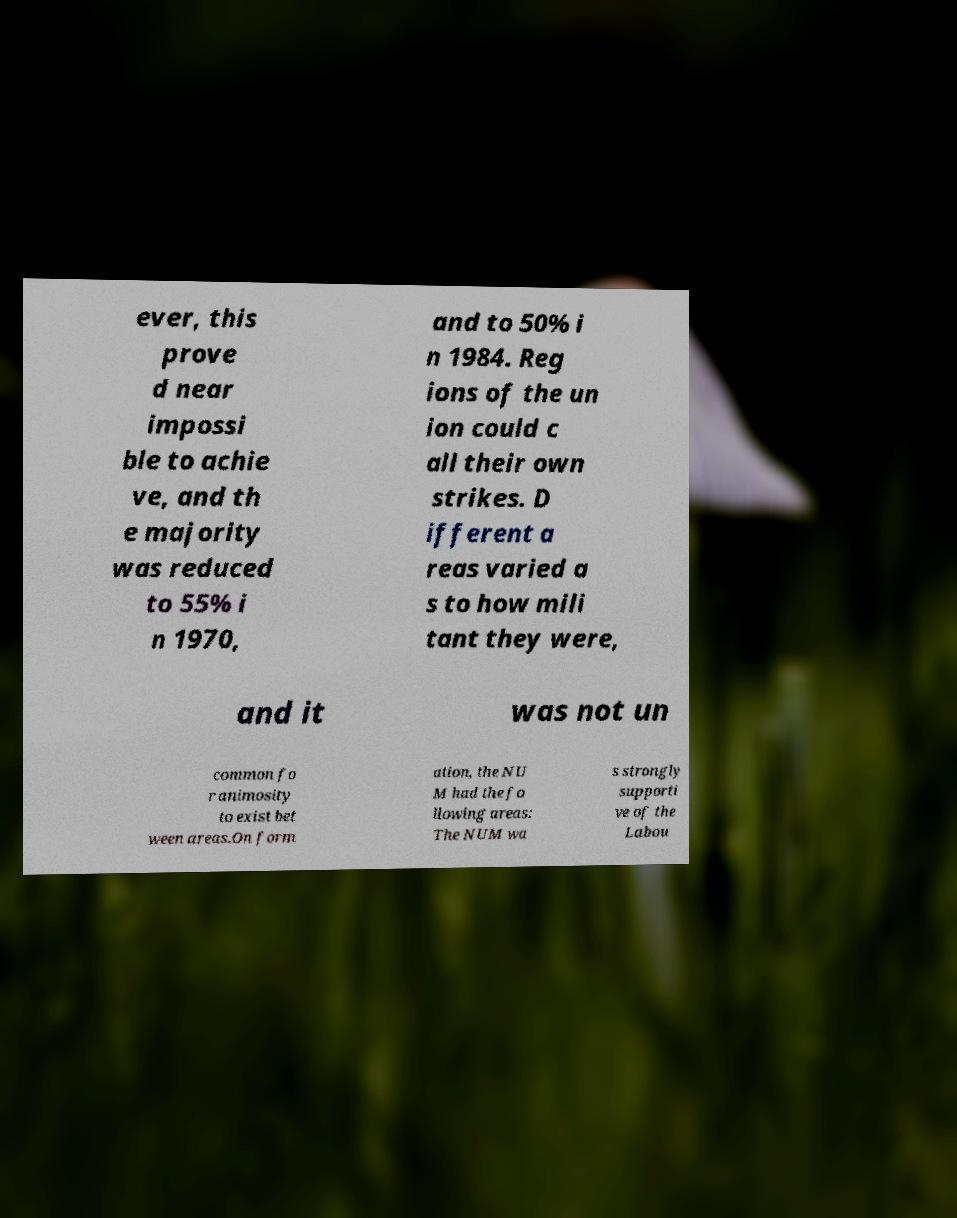Please identify and transcribe the text found in this image. ever, this prove d near impossi ble to achie ve, and th e majority was reduced to 55% i n 1970, and to 50% i n 1984. Reg ions of the un ion could c all their own strikes. D ifferent a reas varied a s to how mili tant they were, and it was not un common fo r animosity to exist bet ween areas.On form ation, the NU M had the fo llowing areas: The NUM wa s strongly supporti ve of the Labou 